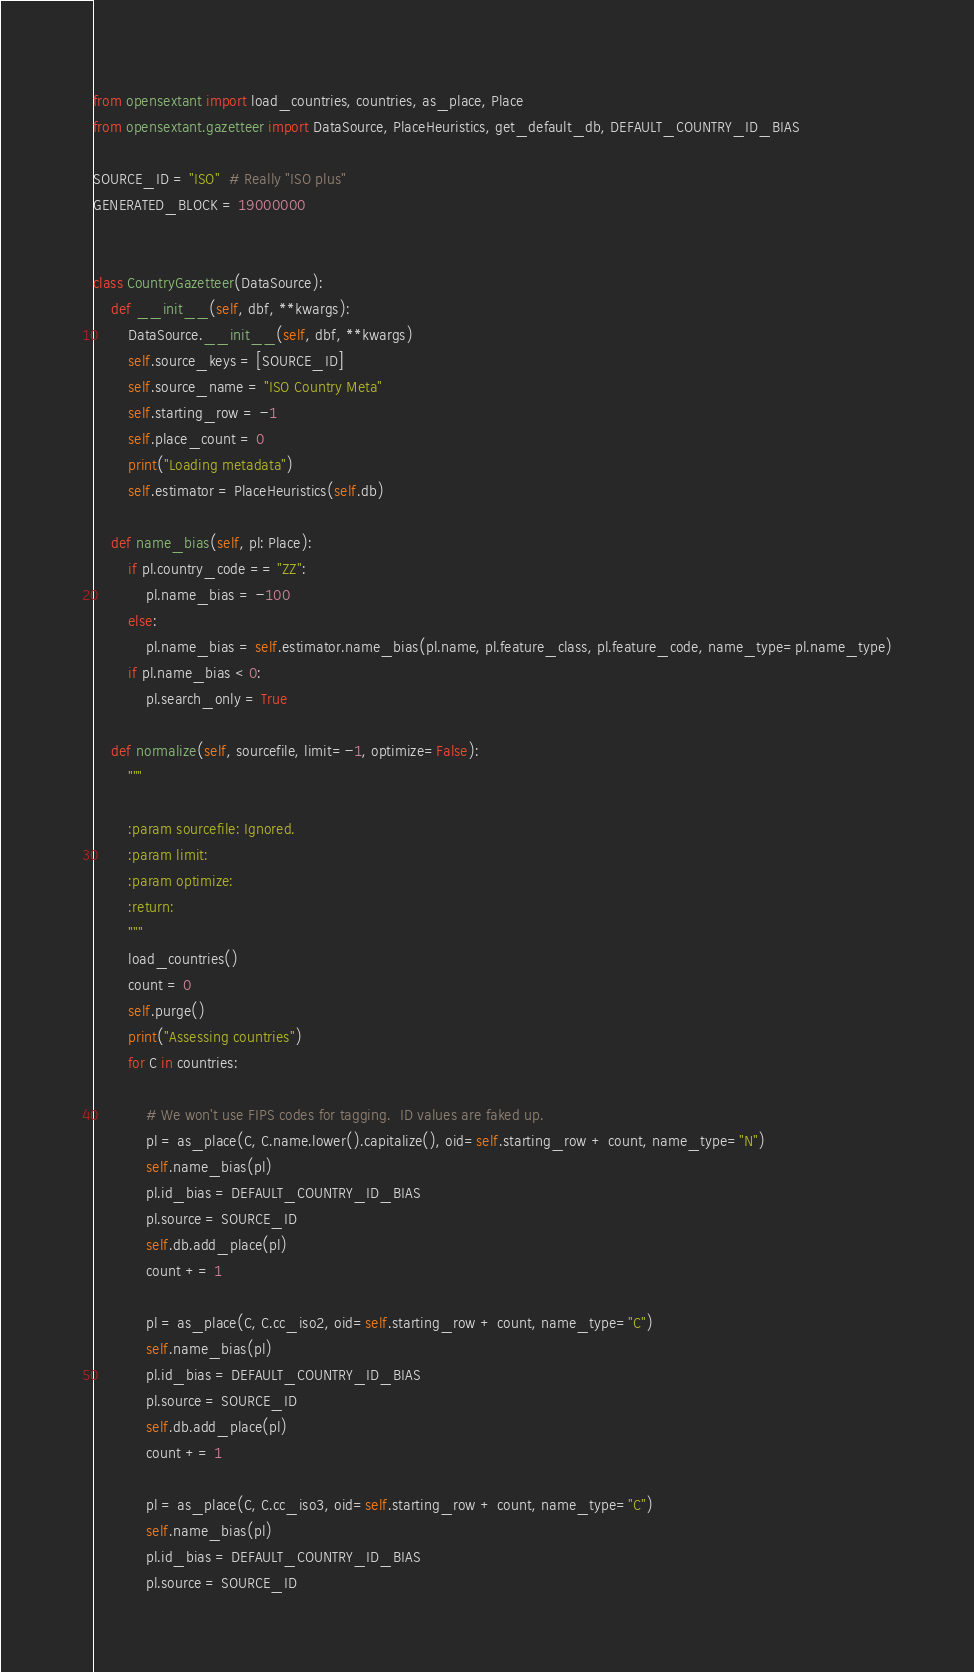Convert code to text. <code><loc_0><loc_0><loc_500><loc_500><_Python_>from opensextant import load_countries, countries, as_place, Place
from opensextant.gazetteer import DataSource, PlaceHeuristics, get_default_db, DEFAULT_COUNTRY_ID_BIAS

SOURCE_ID = "ISO"  # Really "ISO plus"
GENERATED_BLOCK = 19000000


class CountryGazetteer(DataSource):
    def __init__(self, dbf, **kwargs):
        DataSource.__init__(self, dbf, **kwargs)
        self.source_keys = [SOURCE_ID]
        self.source_name = "ISO Country Meta"
        self.starting_row = -1
        self.place_count = 0
        print("Loading metadata")
        self.estimator = PlaceHeuristics(self.db)

    def name_bias(self, pl: Place):
        if pl.country_code == "ZZ":
            pl.name_bias = -100
        else:
            pl.name_bias = self.estimator.name_bias(pl.name, pl.feature_class, pl.feature_code, name_type=pl.name_type)
        if pl.name_bias < 0:
            pl.search_only = True

    def normalize(self, sourcefile, limit=-1, optimize=False):
        """

        :param sourcefile: Ignored.
        :param limit:
        :param optimize:
        :return:
        """
        load_countries()
        count = 0
        self.purge()
        print("Assessing countries")
        for C in countries:

            # We won't use FIPS codes for tagging.  ID values are faked up.
            pl = as_place(C, C.name.lower().capitalize(), oid=self.starting_row + count, name_type="N")
            self.name_bias(pl)
            pl.id_bias = DEFAULT_COUNTRY_ID_BIAS
            pl.source = SOURCE_ID
            self.db.add_place(pl)
            count += 1

            pl = as_place(C, C.cc_iso2, oid=self.starting_row + count, name_type="C")
            self.name_bias(pl)
            pl.id_bias = DEFAULT_COUNTRY_ID_BIAS
            pl.source = SOURCE_ID
            self.db.add_place(pl)
            count += 1

            pl = as_place(C, C.cc_iso3, oid=self.starting_row + count, name_type="C")
            self.name_bias(pl)
            pl.id_bias = DEFAULT_COUNTRY_ID_BIAS
            pl.source = SOURCE_ID</code> 